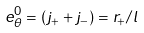Convert formula to latex. <formula><loc_0><loc_0><loc_500><loc_500>e ^ { 0 } _ { \theta } = ( j _ { + } + j _ { - } ) = r _ { + } / l</formula> 